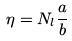<formula> <loc_0><loc_0><loc_500><loc_500>\eta = N _ { l } \frac { a } { b }</formula> 